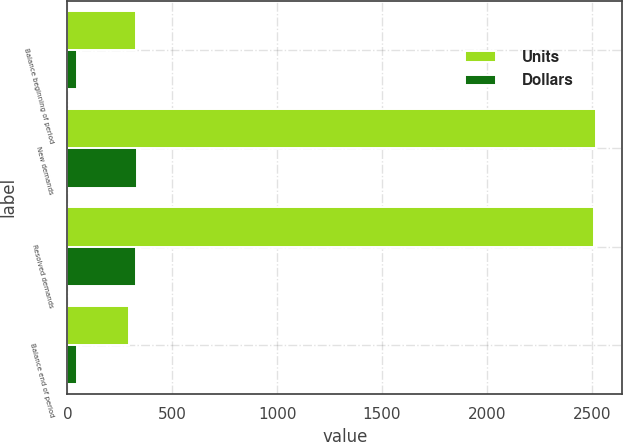<chart> <loc_0><loc_0><loc_500><loc_500><stacked_bar_chart><ecel><fcel>Balance beginning of period<fcel>New demands<fcel>Resolved demands<fcel>Balance end of period<nl><fcel>Units<fcel>328<fcel>2519<fcel>2511<fcel>294<nl><fcel>Dollars<fcel>47<fcel>333<fcel>325<fcel>48<nl></chart> 